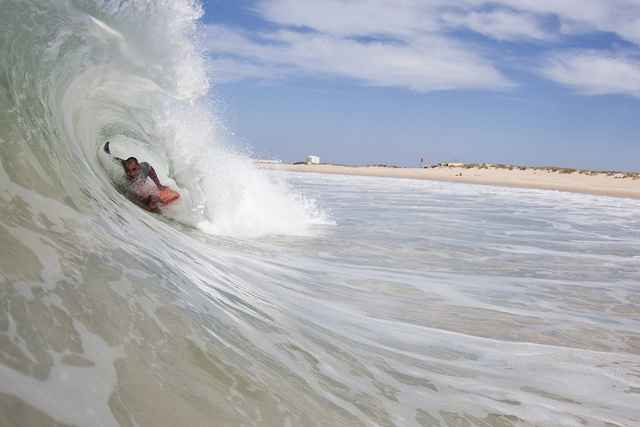Describe the objects in this image and their specific colors. I can see people in gray, maroon, black, and darkgray tones and surfboard in gray, brown, darkgray, and maroon tones in this image. 